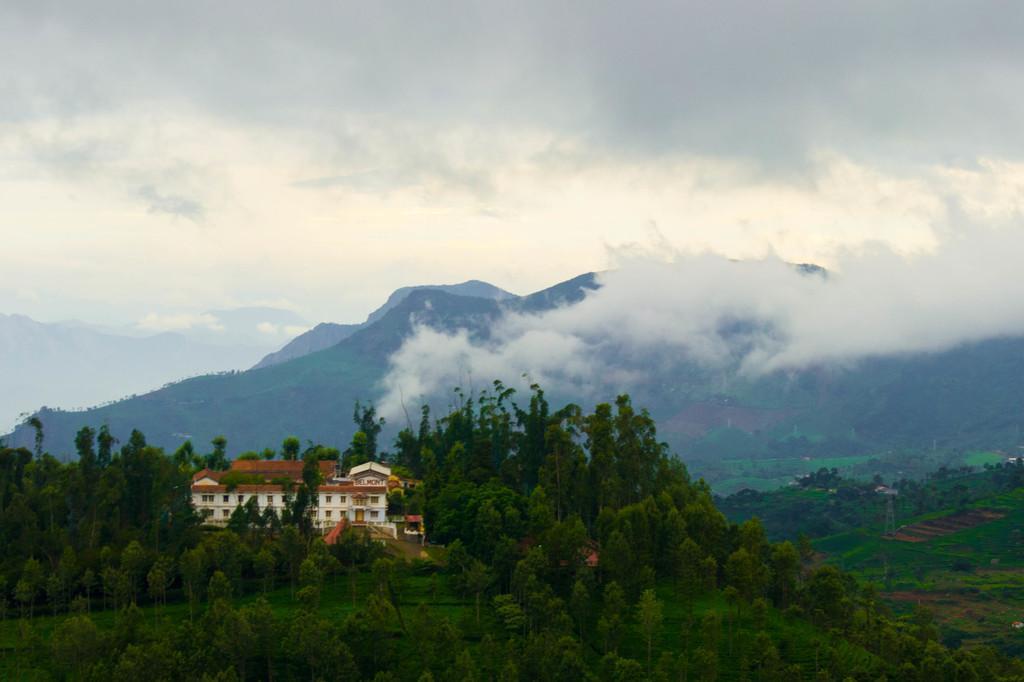How would you summarize this image in a sentence or two? In the image we can see the building and the windows of the building. We can even see the trees, mountains, grass, smoke and the cloudy sky. 